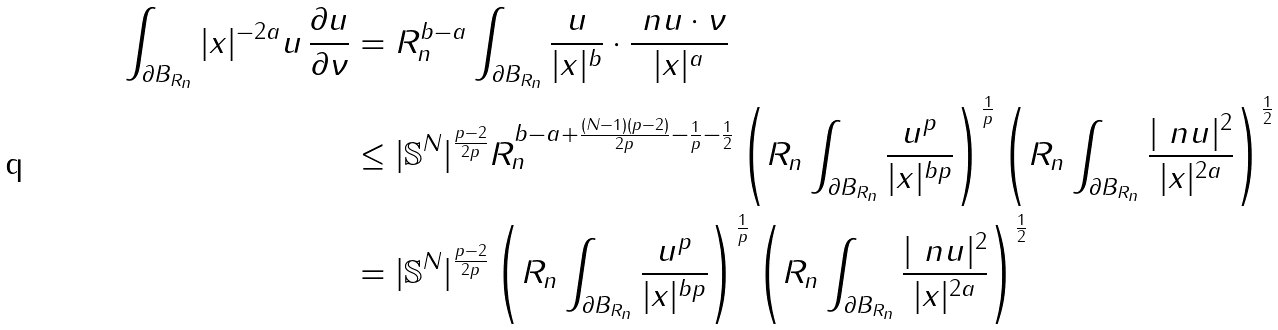Convert formula to latex. <formula><loc_0><loc_0><loc_500><loc_500>\int _ { \partial B _ { R _ { n } } } | x | ^ { - 2 a } u \, \frac { \partial u } { \partial \nu } & = R _ { n } ^ { b - a } \int _ { \partial B _ { R _ { n } } } \frac { u } { | x | ^ { b } } \cdot \frac { \ n u \cdot \nu } { | x | ^ { a } } \\ & \leq | { \mathbb { S } } ^ { N } | ^ { \frac { p - 2 } { 2 p } } R _ { n } ^ { b - a + \frac { ( N - 1 ) ( p - 2 ) } { 2 p } - \frac { 1 } { p } - \frac { 1 } { 2 } } \left ( R _ { n } \int _ { \partial B _ { R _ { n } } } \frac { u ^ { p } } { | x | ^ { b p } } \right ) ^ { \frac { 1 } { p } } \left ( R _ { n } \int _ { \partial B _ { R _ { n } } } \frac { | \ n u | ^ { 2 } } { | x | ^ { 2 a } } \right ) ^ { \frac { 1 } { 2 } } \\ & = | { \mathbb { S } } ^ { N } | ^ { \frac { p - 2 } { 2 p } } \left ( R _ { n } \int _ { \partial B _ { R _ { n } } } \frac { u ^ { p } } { | x | ^ { b p } } \right ) ^ { \frac { 1 } { p } } \left ( R _ { n } \int _ { \partial B _ { R _ { n } } } \frac { | \ n u | ^ { 2 } } { | x | ^ { 2 a } } \right ) ^ { \frac { 1 } { 2 } }</formula> 